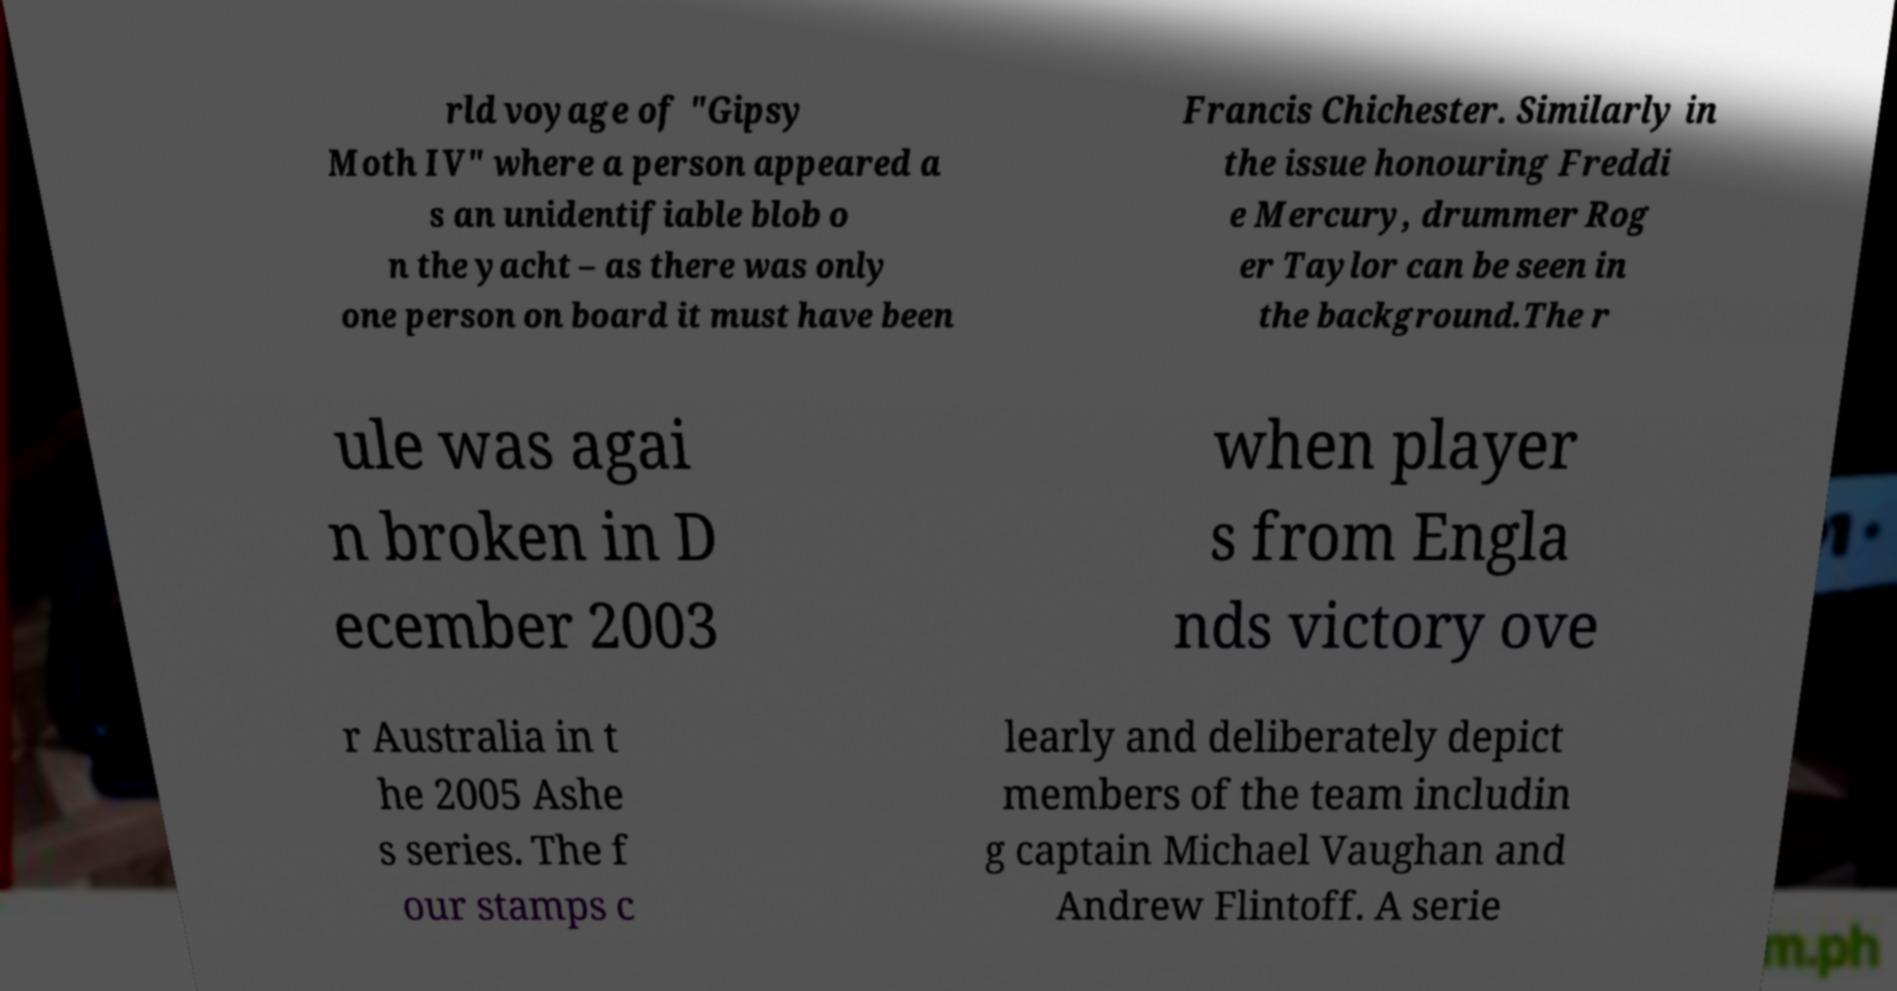I need the written content from this picture converted into text. Can you do that? rld voyage of "Gipsy Moth IV" where a person appeared a s an unidentifiable blob o n the yacht – as there was only one person on board it must have been Francis Chichester. Similarly in the issue honouring Freddi e Mercury, drummer Rog er Taylor can be seen in the background.The r ule was agai n broken in D ecember 2003 when player s from Engla nds victory ove r Australia in t he 2005 Ashe s series. The f our stamps c learly and deliberately depict members of the team includin g captain Michael Vaughan and Andrew Flintoff. A serie 